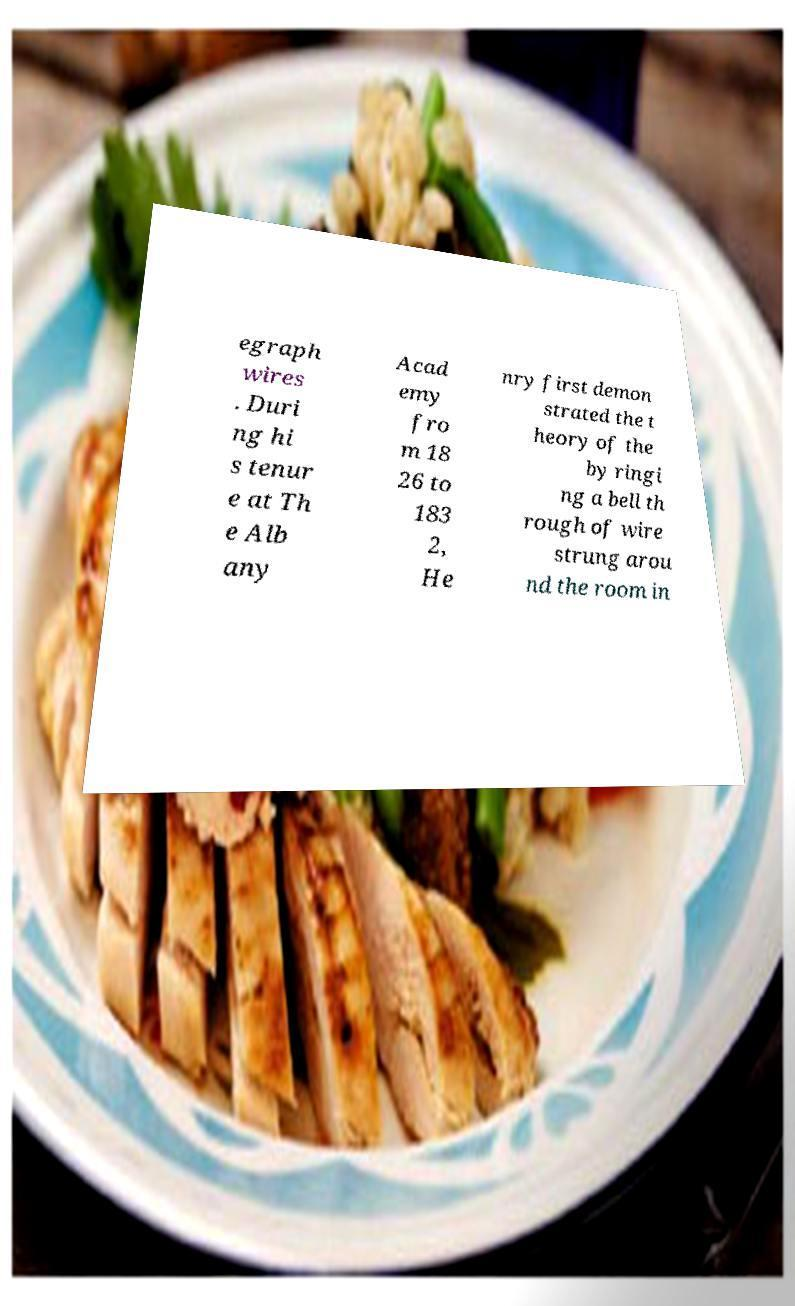I need the written content from this picture converted into text. Can you do that? egraph wires . Duri ng hi s tenur e at Th e Alb any Acad emy fro m 18 26 to 183 2, He nry first demon strated the t heory of the by ringi ng a bell th rough of wire strung arou nd the room in 